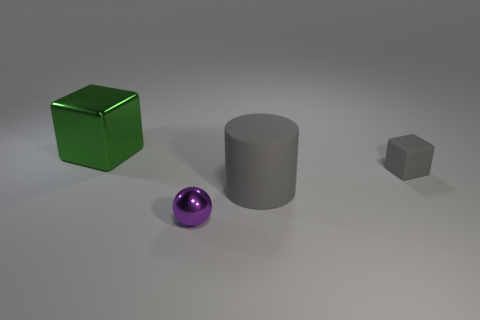The gray rubber object that is the same size as the shiny ball is what shape?
Give a very brief answer. Cube. Is there another tiny object that has the same shape as the green thing?
Your answer should be compact. Yes. Are the large thing in front of the large green metal object and the thing in front of the big rubber cylinder made of the same material?
Provide a short and direct response. No. The tiny rubber object that is the same color as the rubber cylinder is what shape?
Provide a succinct answer. Cube. How many small cubes have the same material as the small purple thing?
Give a very brief answer. 0. The small sphere has what color?
Your answer should be very brief. Purple. There is a rubber thing right of the gray rubber cylinder; does it have the same shape as the large thing to the right of the big metal object?
Keep it short and to the point. No. The metal object that is right of the big green object is what color?
Your answer should be very brief. Purple. Is the number of metal spheres in front of the sphere less than the number of large things on the right side of the big shiny object?
Ensure brevity in your answer.  Yes. How many other things are there of the same material as the tiny cube?
Your response must be concise. 1. 